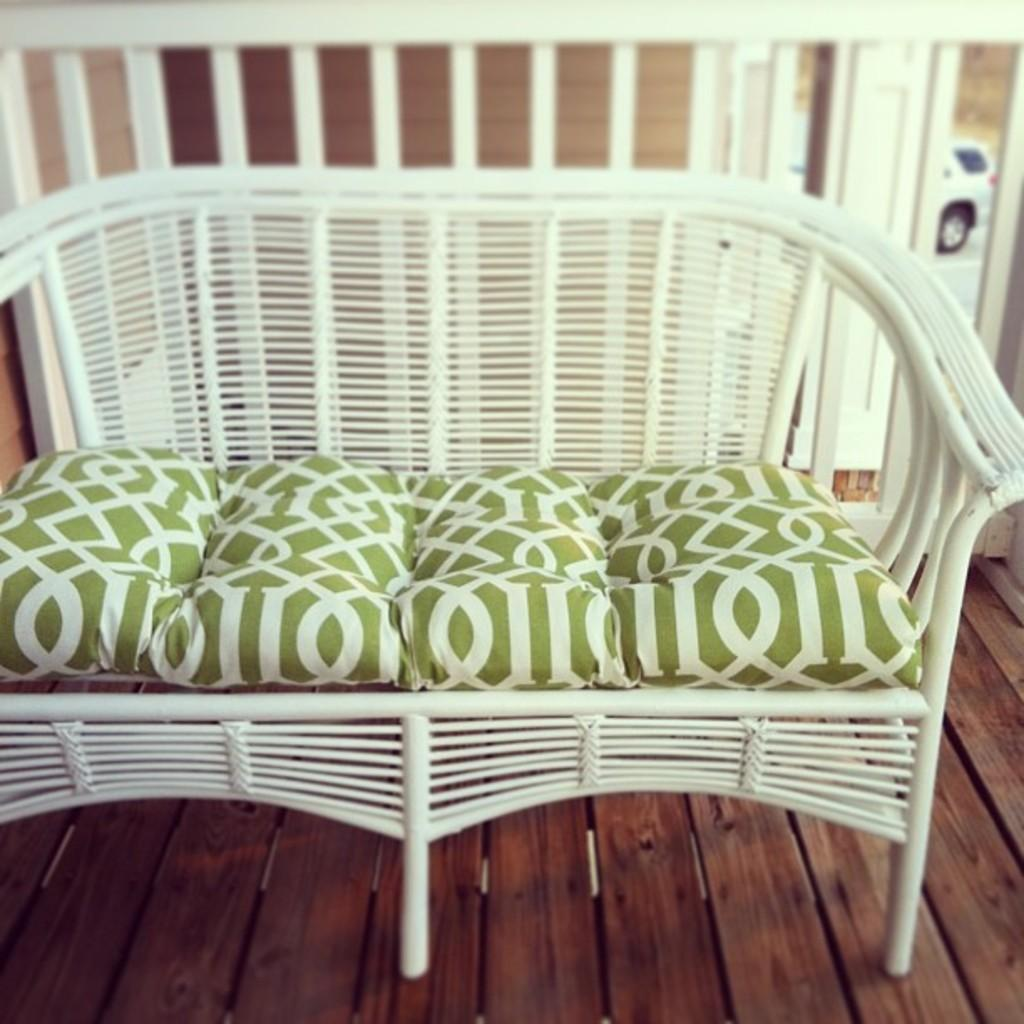What type of furniture is on the wooden surface in the image? There is a sofa on a wooden surface in the image. What is placed on the sofa? There are pillows on the sofa. What can be seen behind the wooden surface? There is a fence at the back in the image. What mode of transportation can be seen on the road? A car is visible on the road in the image. What color is the robin sitting on the fence in the image? There is no robin present in the image; it only features a sofa, pillows, a fence, and a car on the road. 